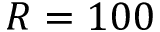Convert formula to latex. <formula><loc_0><loc_0><loc_500><loc_500>R = 1 0 0</formula> 